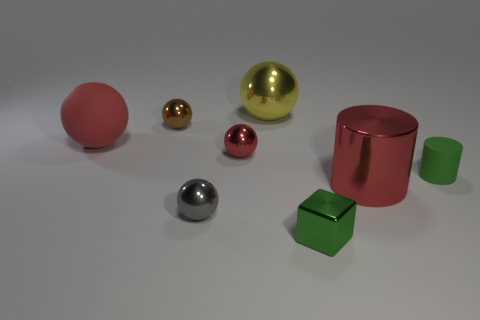Subtract all small brown metal spheres. How many spheres are left? 4 Add 1 red things. How many objects exist? 9 Subtract all green cylinders. How many cylinders are left? 1 Subtract all brown blocks. How many red balls are left? 2 Subtract 1 red cylinders. How many objects are left? 7 Subtract all balls. How many objects are left? 3 Subtract 1 cylinders. How many cylinders are left? 1 Subtract all brown cylinders. Subtract all purple balls. How many cylinders are left? 2 Subtract all shiny blocks. Subtract all green things. How many objects are left? 5 Add 1 large yellow things. How many large yellow things are left? 2 